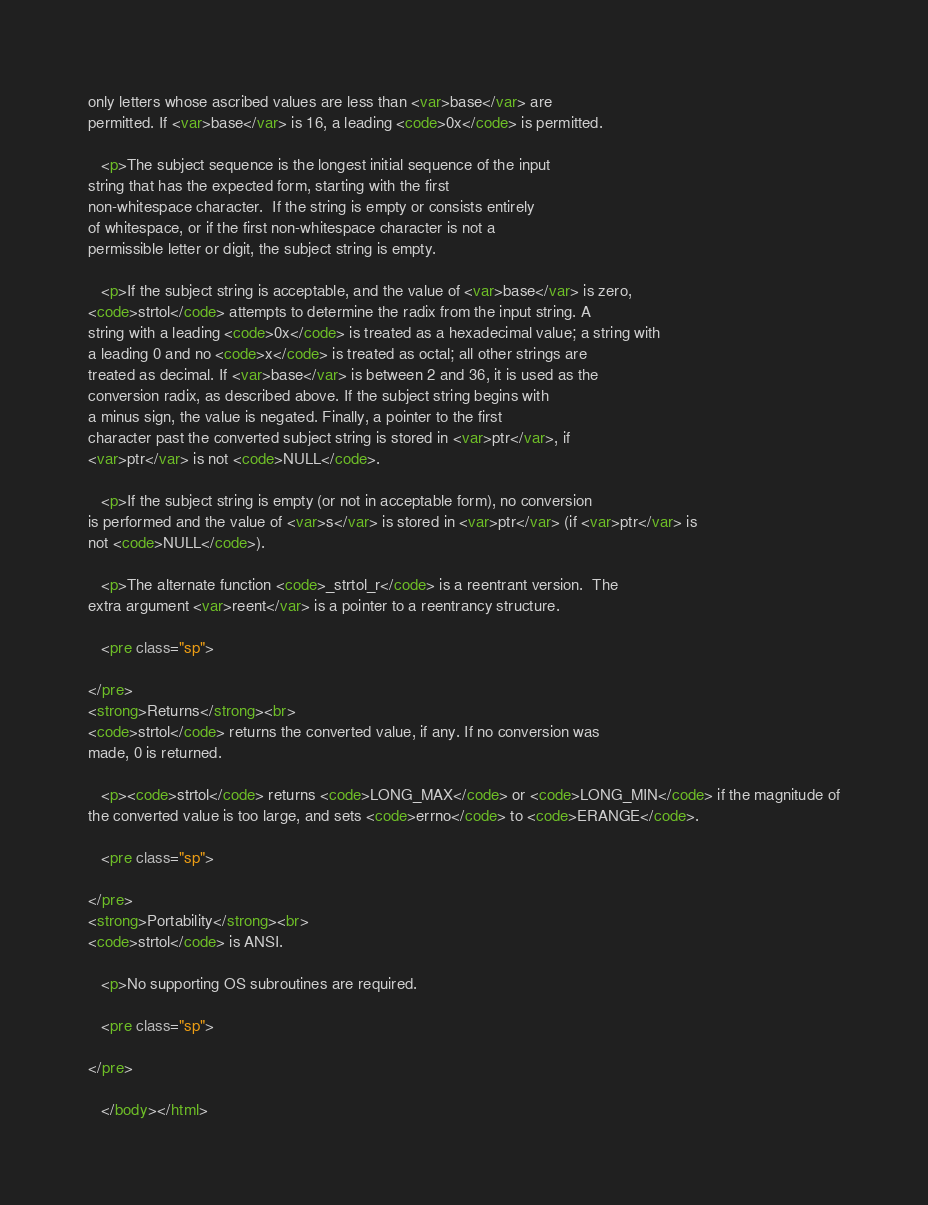<code> <loc_0><loc_0><loc_500><loc_500><_HTML_>only letters whose ascribed values are less than <var>base</var> are
permitted. If <var>base</var> is 16, a leading <code>0x</code> is permitted.

   <p>The subject sequence is the longest initial sequence of the input
string that has the expected form, starting with the first
non-whitespace character.  If the string is empty or consists entirely
of whitespace, or if the first non-whitespace character is not a
permissible letter or digit, the subject string is empty.

   <p>If the subject string is acceptable, and the value of <var>base</var> is zero,
<code>strtol</code> attempts to determine the radix from the input string. A
string with a leading <code>0x</code> is treated as a hexadecimal value; a string with
a leading 0 and no <code>x</code> is treated as octal; all other strings are
treated as decimal. If <var>base</var> is between 2 and 36, it is used as the
conversion radix, as described above. If the subject string begins with
a minus sign, the value is negated. Finally, a pointer to the first
character past the converted subject string is stored in <var>ptr</var>, if
<var>ptr</var> is not <code>NULL</code>.

   <p>If the subject string is empty (or not in acceptable form), no conversion
is performed and the value of <var>s</var> is stored in <var>ptr</var> (if <var>ptr</var> is
not <code>NULL</code>).

   <p>The alternate function <code>_strtol_r</code> is a reentrant version.  The
extra argument <var>reent</var> is a pointer to a reentrancy structure.

   <pre class="sp">

</pre>
<strong>Returns</strong><br>
<code>strtol</code> returns the converted value, if any. If no conversion was
made, 0 is returned.

   <p><code>strtol</code> returns <code>LONG_MAX</code> or <code>LONG_MIN</code> if the magnitude of
the converted value is too large, and sets <code>errno</code> to <code>ERANGE</code>.

   <pre class="sp">

</pre>
<strong>Portability</strong><br>
<code>strtol</code> is ANSI.

   <p>No supporting OS subroutines are required.

   <pre class="sp">

</pre>

   </body></html>

</code> 